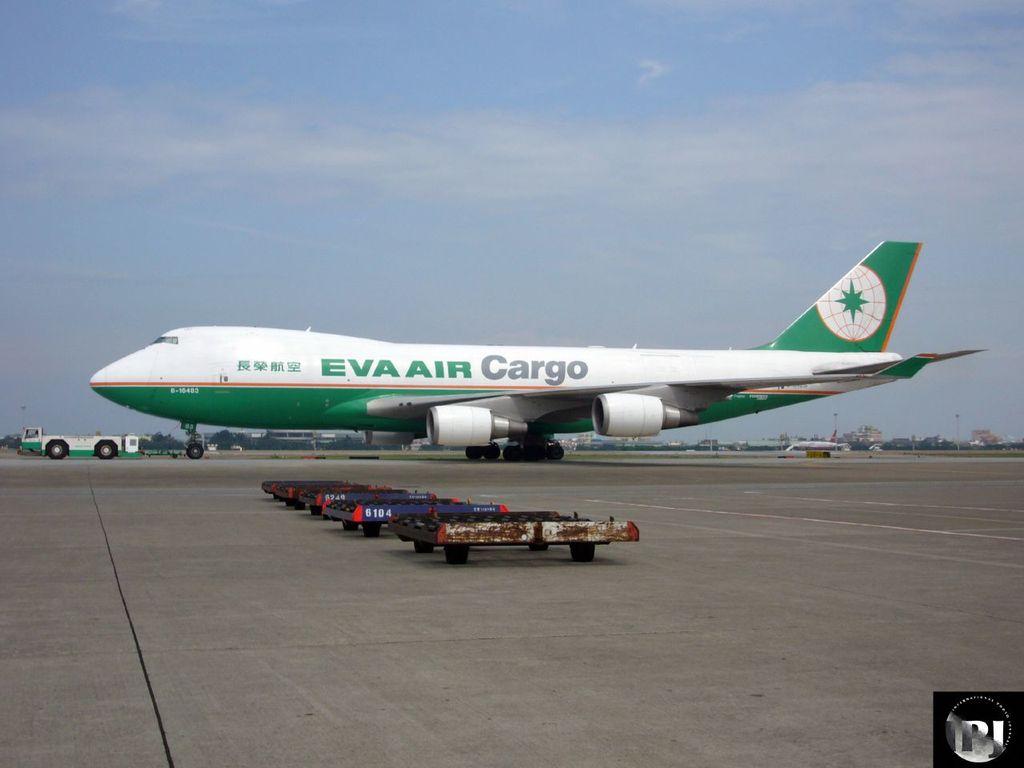What plane company is that?
Give a very brief answer. Eva air. 